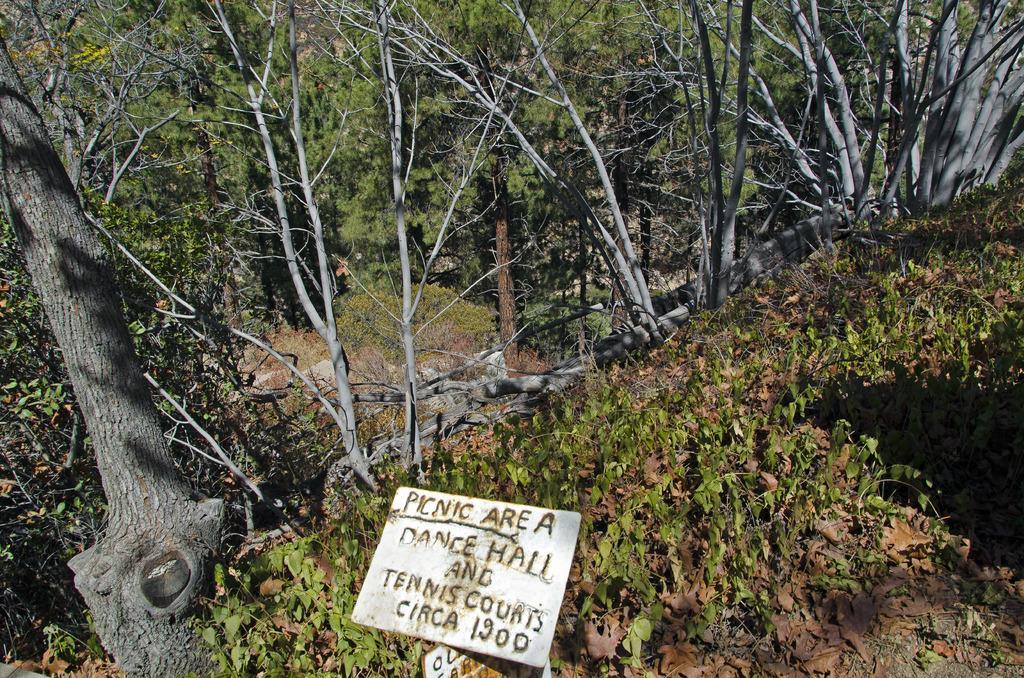How would you summarize this image in a sentence or two? At the bottom of the image there is a board. In the background we can see trees, plants and grass. 